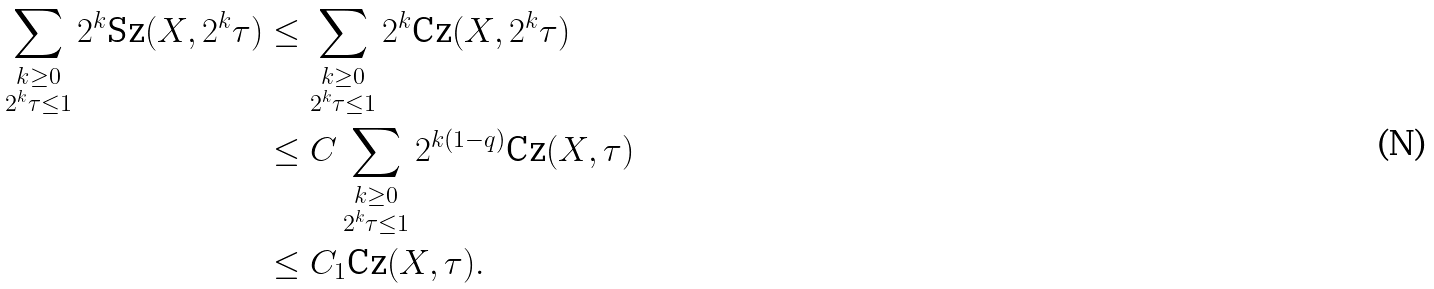<formula> <loc_0><loc_0><loc_500><loc_500>\sum _ { \substack { k \geq 0 \\ 2 ^ { k } \tau \leq 1 } } 2 ^ { k } \text {Sz} ( X , 2 ^ { k } \tau ) & \leq \sum _ { \substack { k \geq 0 \\ 2 ^ { k } \tau \leq 1 } } 2 ^ { k } \text {Cz} ( X , 2 ^ { k } \tau ) \\ & \leq C \sum _ { \substack { k \geq 0 \\ 2 ^ { k } \tau \leq 1 } } 2 ^ { k ( 1 - q ) } \text {Cz} ( X , \tau ) \\ & \leq C _ { 1 } \text {Cz} ( X , \tau ) .</formula> 